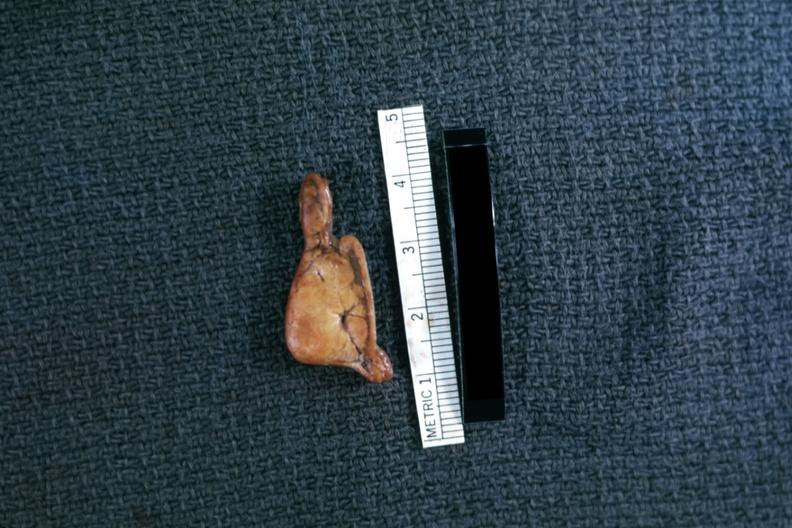does this image show fixed tissue but very good example in cross section?
Answer the question using a single word or phrase. Yes 